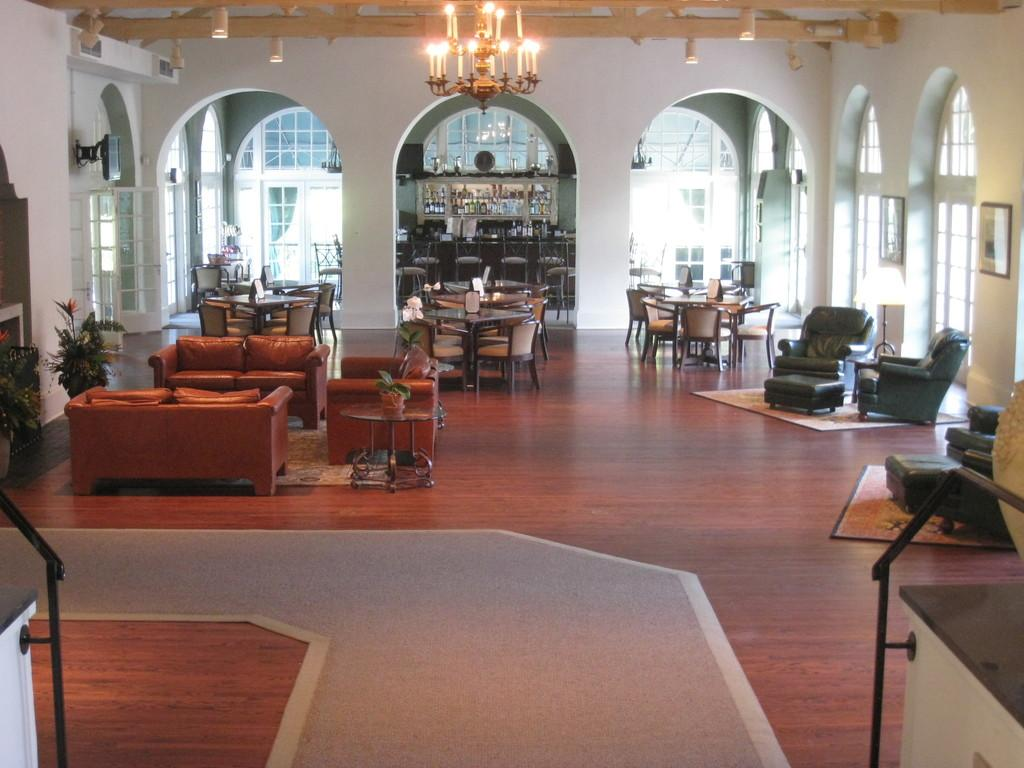What type of space is shown in the image? The image depicts a room. What furniture can be seen in the room? There are different tables and couches in the room. Is there any source of light visible in the image? Yes, there is a light visible at the top of the image. How many chairs are being destroyed in the image? There are no chairs or destruction present in the image. 